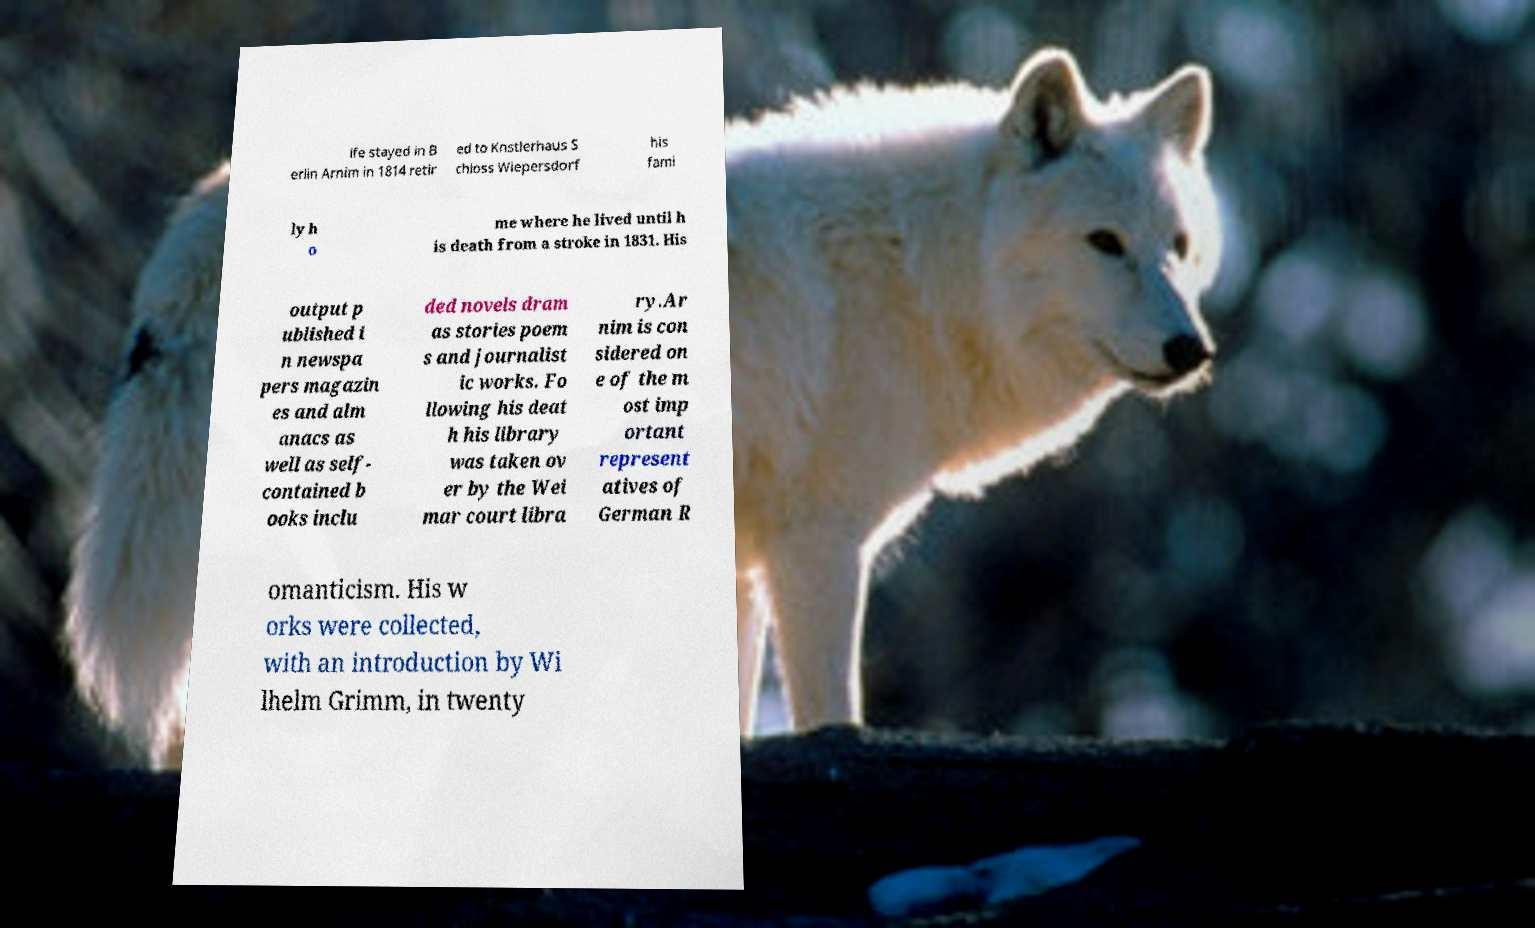Could you assist in decoding the text presented in this image and type it out clearly? ife stayed in B erlin Arnim in 1814 retir ed to Knstlerhaus S chloss Wiepersdorf his fami ly h o me where he lived until h is death from a stroke in 1831. His output p ublished i n newspa pers magazin es and alm anacs as well as self- contained b ooks inclu ded novels dram as stories poem s and journalist ic works. Fo llowing his deat h his library was taken ov er by the Wei mar court libra ry.Ar nim is con sidered on e of the m ost imp ortant represent atives of German R omanticism. His w orks were collected, with an introduction by Wi lhelm Grimm, in twenty 